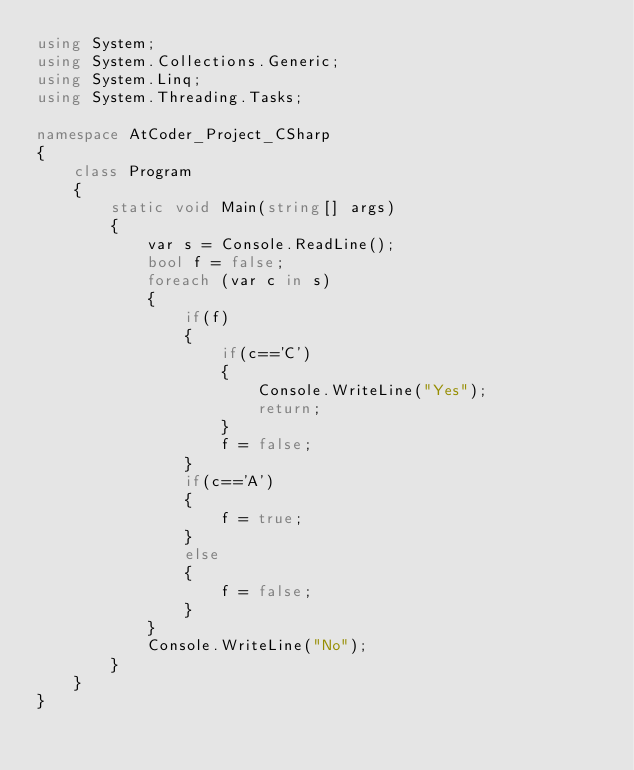Convert code to text. <code><loc_0><loc_0><loc_500><loc_500><_C#_>using System;
using System.Collections.Generic;
using System.Linq;
using System.Threading.Tasks;

namespace AtCoder_Project_CSharp
{
    class Program
    {
        static void Main(string[] args)
        {
            var s = Console.ReadLine();
            bool f = false;
            foreach (var c in s)
            {
                if(f)
                {
                    if(c=='C')
                    {
                        Console.WriteLine("Yes");
                        return;
                    }
                    f = false;
                }
                if(c=='A')
                {
                    f = true;
                }
                else
                {
                    f = false;
                }
            }
            Console.WriteLine("No");
        }
    }
}
</code> 